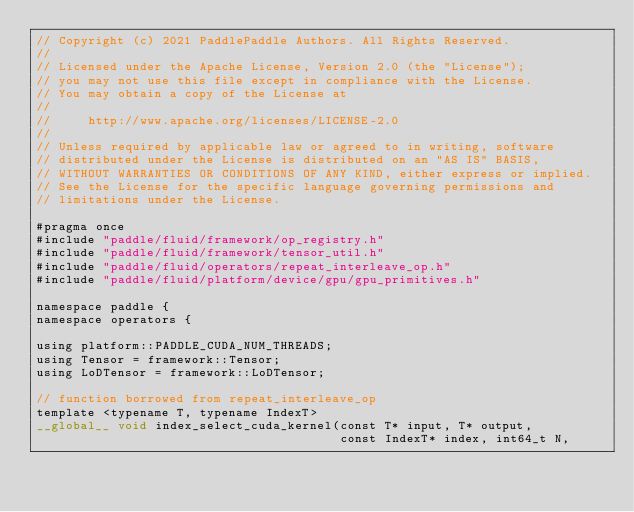<code> <loc_0><loc_0><loc_500><loc_500><_Cuda_>// Copyright (c) 2021 PaddlePaddle Authors. All Rights Reserved.
//
// Licensed under the Apache License, Version 2.0 (the "License");
// you may not use this file except in compliance with the License.
// You may obtain a copy of the License at
//
//     http://www.apache.org/licenses/LICENSE-2.0
//
// Unless required by applicable law or agreed to in writing, software
// distributed under the License is distributed on an "AS IS" BASIS,
// WITHOUT WARRANTIES OR CONDITIONS OF ANY KIND, either express or implied.
// See the License for the specific language governing permissions and
// limitations under the License.

#pragma once
#include "paddle/fluid/framework/op_registry.h"
#include "paddle/fluid/framework/tensor_util.h"
#include "paddle/fluid/operators/repeat_interleave_op.h"
#include "paddle/fluid/platform/device/gpu/gpu_primitives.h"

namespace paddle {
namespace operators {

using platform::PADDLE_CUDA_NUM_THREADS;
using Tensor = framework::Tensor;
using LoDTensor = framework::LoDTensor;

// function borrowed from repeat_interleave_op
template <typename T, typename IndexT>
__global__ void index_select_cuda_kernel(const T* input, T* output,
                                         const IndexT* index, int64_t N,</code> 